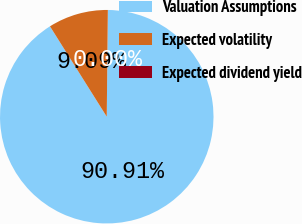Convert chart to OTSL. <chart><loc_0><loc_0><loc_500><loc_500><pie_chart><fcel>Valuation Assumptions<fcel>Expected volatility<fcel>Expected dividend yield<nl><fcel>90.9%<fcel>9.09%<fcel>0.0%<nl></chart> 